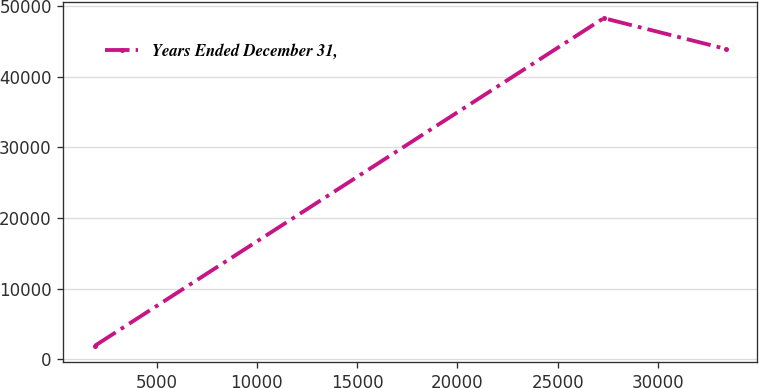Convert chart to OTSL. <chart><loc_0><loc_0><loc_500><loc_500><line_chart><ecel><fcel>Years Ended December 31,<nl><fcel>1931.63<fcel>1930.68<nl><fcel>27293.6<fcel>48266.1<nl><fcel>33375.2<fcel>43917.8<nl></chart> 